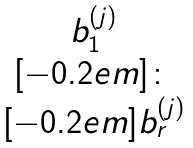<formula> <loc_0><loc_0><loc_500><loc_500>\begin{matrix} b _ { 1 } ^ { ( j ) } \\ [ - 0 . 2 e m ] \colon \\ [ - 0 . 2 e m ] b _ { r } ^ { ( j ) } \end{matrix}</formula> 